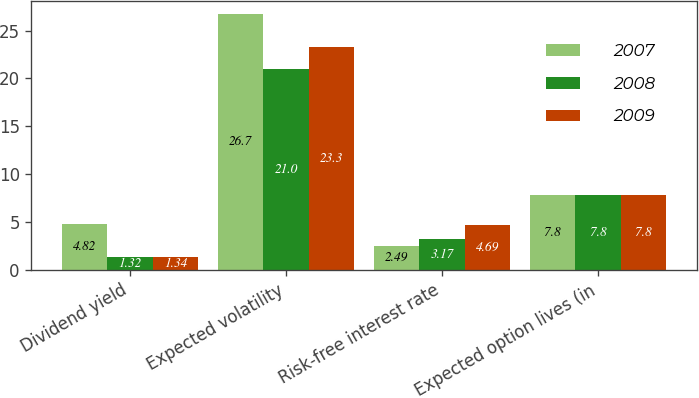Convert chart. <chart><loc_0><loc_0><loc_500><loc_500><stacked_bar_chart><ecel><fcel>Dividend yield<fcel>Expected volatility<fcel>Risk-free interest rate<fcel>Expected option lives (in<nl><fcel>2007<fcel>4.82<fcel>26.7<fcel>2.49<fcel>7.8<nl><fcel>2008<fcel>1.32<fcel>21<fcel>3.17<fcel>7.8<nl><fcel>2009<fcel>1.34<fcel>23.3<fcel>4.69<fcel>7.8<nl></chart> 